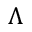<formula> <loc_0><loc_0><loc_500><loc_500>\Lambda</formula> 